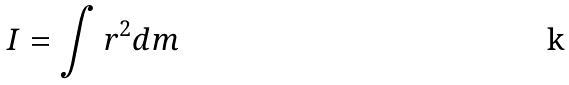<formula> <loc_0><loc_0><loc_500><loc_500>I = \int r ^ { 2 } d m</formula> 